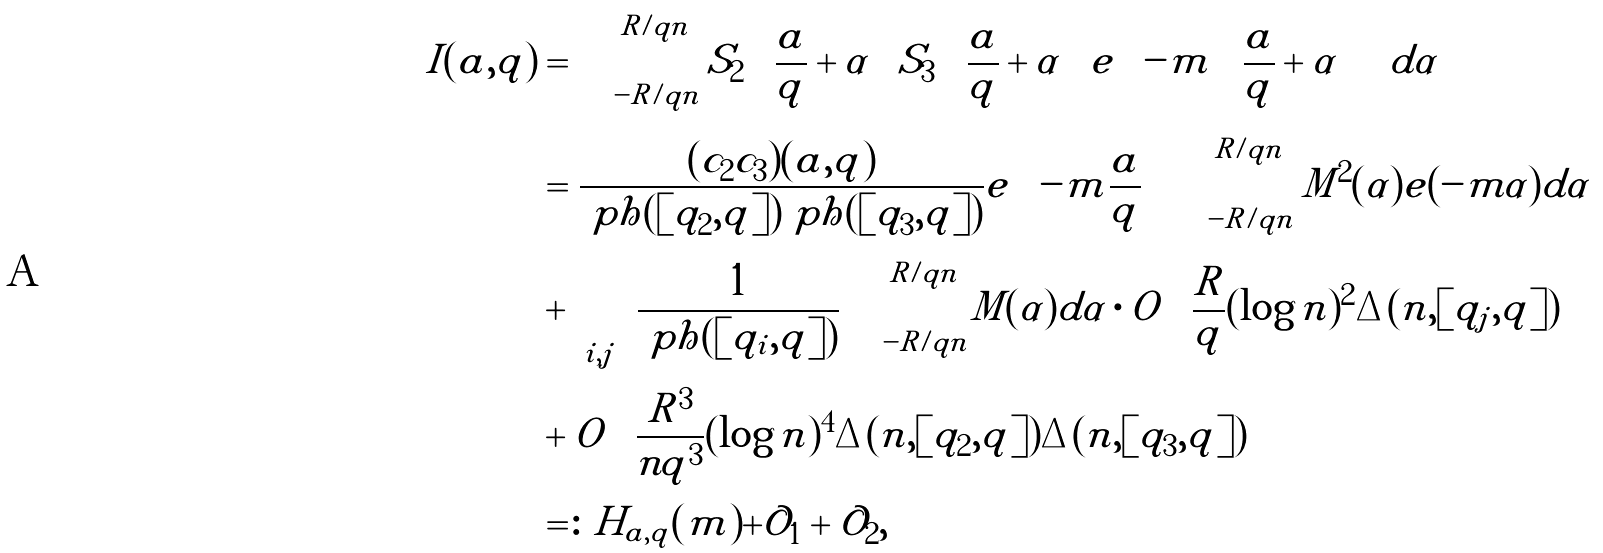<formula> <loc_0><loc_0><loc_500><loc_500>I ( a , q ) & = \int _ { - R / q n } ^ { R / q n } S _ { 2 } \left ( \frac { a } { q } + \alpha \right ) S _ { 3 } \left ( \frac { a } { q } + \alpha \right ) e \left ( - m \left ( \frac { a } { q } + \alpha \right ) \right ) d \alpha \\ & = \frac { ( c _ { 2 } c _ { 3 } ) ( a , q ) } { \ p h ( [ q _ { 2 } , q ] ) \ p h ( [ q _ { 3 } , q ] ) } e \left ( - m \frac { a } { q } \right ) \int _ { - R / q n } ^ { R / q n } M ^ { 2 } ( \alpha ) e ( - m \alpha ) d \alpha \\ & + \sum _ { i , j } \frac { 1 } { \ p h ( [ q _ { i } , q ] ) } \int _ { - R / q n } ^ { R / q n } | M ( \alpha ) | d \alpha \cdot O \left ( \frac { R } { q } ( \log n ) ^ { 2 } \Delta ( n , [ q _ { j } , q ] ) \right ) \\ & + O \left ( \frac { R ^ { 3 } } { n q ^ { 3 } } ( \log n ) ^ { 4 } \Delta ( n , [ q _ { 2 } , q ] ) \Delta ( n , [ q _ { 3 } , q ] ) \right ) \\ & = \colon H _ { a , q } ( m ) + \mathcal { O } _ { 1 } + \mathcal { O } _ { 2 } ,</formula> 